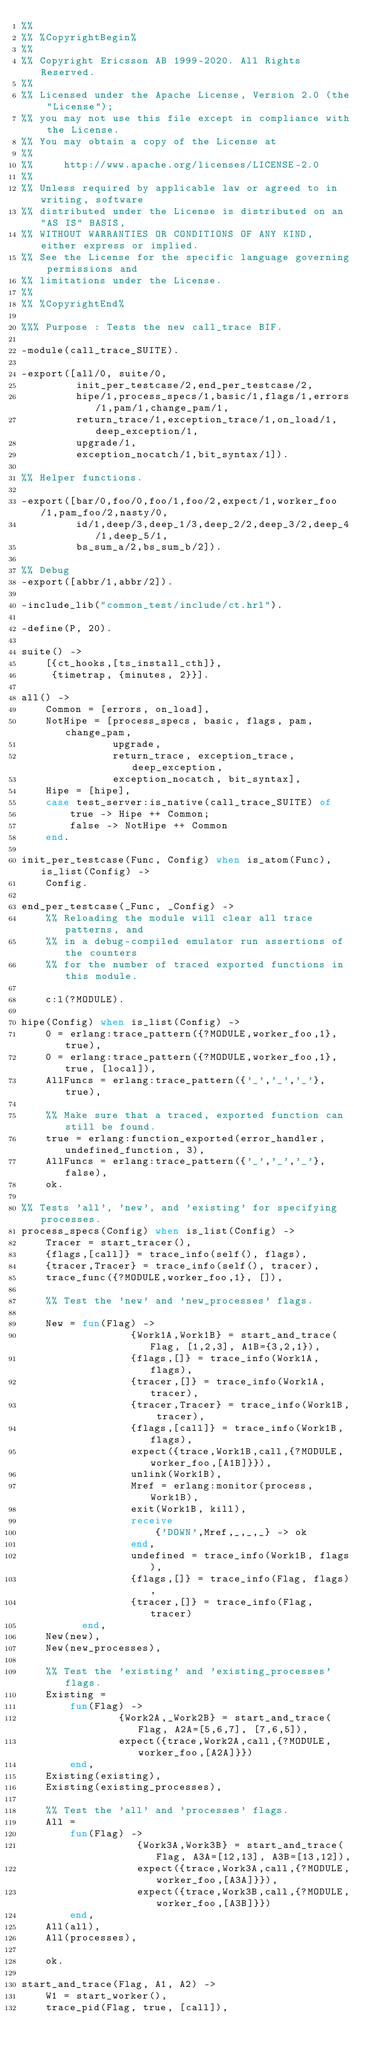<code> <loc_0><loc_0><loc_500><loc_500><_Erlang_>%%
%% %CopyrightBegin%
%% 
%% Copyright Ericsson AB 1999-2020. All Rights Reserved.
%% 
%% Licensed under the Apache License, Version 2.0 (the "License");
%% you may not use this file except in compliance with the License.
%% You may obtain a copy of the License at
%%
%%     http://www.apache.org/licenses/LICENSE-2.0
%%
%% Unless required by applicable law or agreed to in writing, software
%% distributed under the License is distributed on an "AS IS" BASIS,
%% WITHOUT WARRANTIES OR CONDITIONS OF ANY KIND, either express or implied.
%% See the License for the specific language governing permissions and
%% limitations under the License.
%% 
%% %CopyrightEnd%

%%% Purpose : Tests the new call_trace BIF.

-module(call_trace_SUITE).

-export([all/0, suite/0,
         init_per_testcase/2,end_per_testcase/2,
         hipe/1,process_specs/1,basic/1,flags/1,errors/1,pam/1,change_pam/1,
         return_trace/1,exception_trace/1,on_load/1,deep_exception/1,
         upgrade/1,
         exception_nocatch/1,bit_syntax/1]).

%% Helper functions.

-export([bar/0,foo/0,foo/1,foo/2,expect/1,worker_foo/1,pam_foo/2,nasty/0,
         id/1,deep/3,deep_1/3,deep_2/2,deep_3/2,deep_4/1,deep_5/1,
         bs_sum_a/2,bs_sum_b/2]).

%% Debug
-export([abbr/1,abbr/2]).

-include_lib("common_test/include/ct.hrl").

-define(P, 20).

suite() ->
    [{ct_hooks,[ts_install_cth]},
     {timetrap, {minutes, 2}}].

all() ->
    Common = [errors, on_load],
    NotHipe = [process_specs, basic, flags, pam, change_pam,
               upgrade,
               return_trace, exception_trace, deep_exception,
               exception_nocatch, bit_syntax],
    Hipe = [hipe],
    case test_server:is_native(call_trace_SUITE) of
        true -> Hipe ++ Common;
        false -> NotHipe ++ Common
    end.

init_per_testcase(Func, Config) when is_atom(Func), is_list(Config) ->
    Config.

end_per_testcase(_Func, _Config) ->
    %% Reloading the module will clear all trace patterns, and
    %% in a debug-compiled emulator run assertions of the counters
    %% for the number of traced exported functions in this module.

    c:l(?MODULE).

hipe(Config) when is_list(Config) ->
    0 = erlang:trace_pattern({?MODULE,worker_foo,1}, true),
    0 = erlang:trace_pattern({?MODULE,worker_foo,1}, true, [local]),
    AllFuncs = erlang:trace_pattern({'_','_','_'}, true),

    %% Make sure that a traced, exported function can still be found.
    true = erlang:function_exported(error_handler, undefined_function, 3),
    AllFuncs = erlang:trace_pattern({'_','_','_'}, false),
    ok.

%% Tests 'all', 'new', and 'existing' for specifying processes.
process_specs(Config) when is_list(Config) ->
    Tracer = start_tracer(),
    {flags,[call]} = trace_info(self(), flags),
    {tracer,Tracer} = trace_info(self(), tracer),
    trace_func({?MODULE,worker_foo,1}, []),

    %% Test the 'new' and 'new_processes' flags.

    New = fun(Flag) ->
                  {Work1A,Work1B} = start_and_trace(Flag, [1,2,3], A1B={3,2,1}),
                  {flags,[]} = trace_info(Work1A, flags),
                  {tracer,[]} = trace_info(Work1A, tracer),
                  {tracer,Tracer} = trace_info(Work1B, tracer),
                  {flags,[call]} = trace_info(Work1B, flags),
                  expect({trace,Work1B,call,{?MODULE,worker_foo,[A1B]}}),
                  unlink(Work1B),
                  Mref = erlang:monitor(process, Work1B),
                  exit(Work1B, kill),
                  receive
                      {'DOWN',Mref,_,_,_} -> ok
                  end,
                  undefined = trace_info(Work1B, flags),
                  {flags,[]} = trace_info(Flag, flags),
                  {tracer,[]} = trace_info(Flag, tracer)
          end,
    New(new),
    New(new_processes),

    %% Test the 'existing' and 'existing_processes' flags.
    Existing =
        fun(Flag) ->
                {Work2A,_Work2B} = start_and_trace(Flag, A2A=[5,6,7], [7,6,5]),
                expect({trace,Work2A,call,{?MODULE,worker_foo,[A2A]}})
        end,
    Existing(existing),
    Existing(existing_processes),

    %% Test the 'all' and 'processes' flags.
    All =
        fun(Flag) ->
                   {Work3A,Work3B} = start_and_trace(Flag, A3A=[12,13], A3B=[13,12]),
                   expect({trace,Work3A,call,{?MODULE,worker_foo,[A3A]}}),
                   expect({trace,Work3B,call,{?MODULE,worker_foo,[A3B]}})
        end,
    All(all),
    All(processes),

    ok.

start_and_trace(Flag, A1, A2) ->
    W1 = start_worker(),
    trace_pid(Flag, true, [call]),</code> 